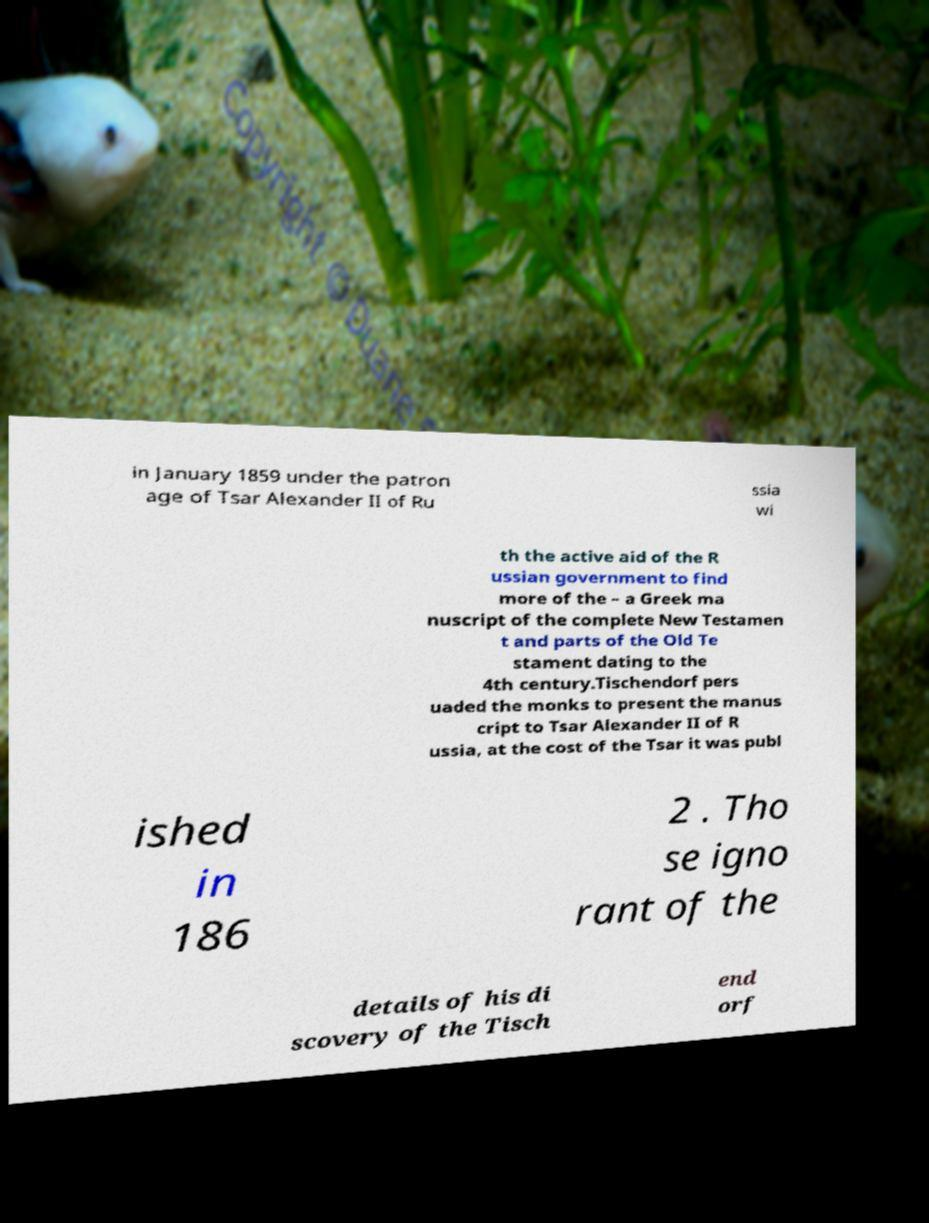For documentation purposes, I need the text within this image transcribed. Could you provide that? in January 1859 under the patron age of Tsar Alexander II of Ru ssia wi th the active aid of the R ussian government to find more of the – a Greek ma nuscript of the complete New Testamen t and parts of the Old Te stament dating to the 4th century.Tischendorf pers uaded the monks to present the manus cript to Tsar Alexander II of R ussia, at the cost of the Tsar it was publ ished in 186 2 . Tho se igno rant of the details of his di scovery of the Tisch end orf 